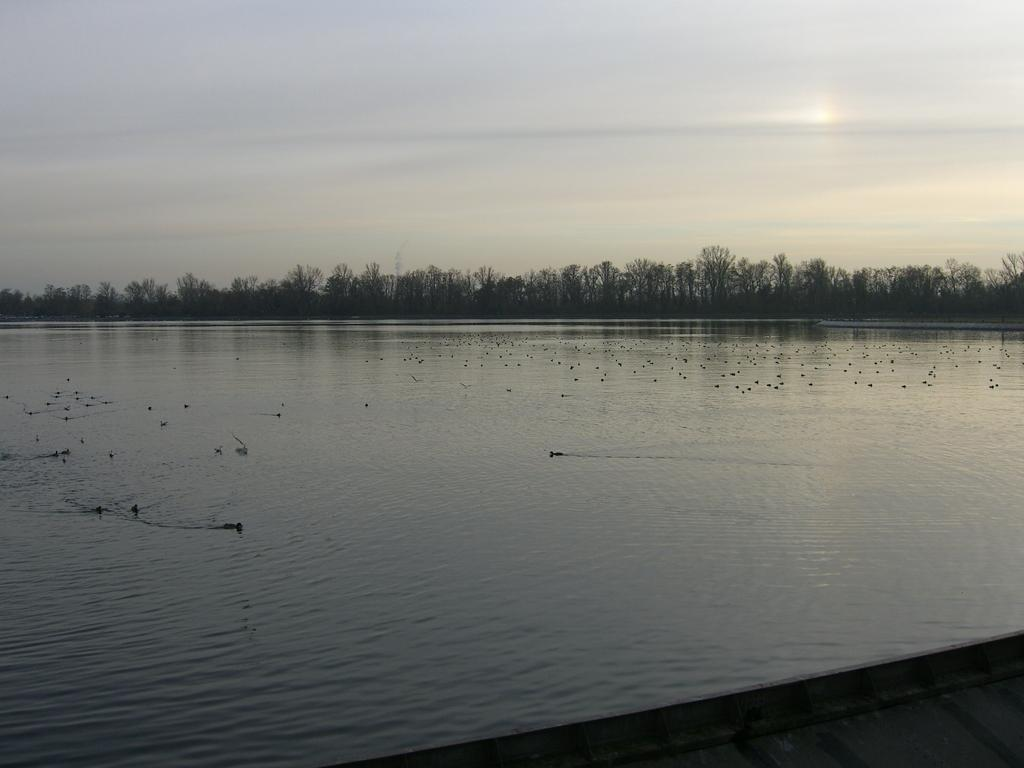What is the main feature of the image? There is a river in the picture. What are the birds doing in the image? The birds are swimming in the water. What can be seen in the background of the image? There are trees in the backdrop of the image. How would you describe the weather in the image? The sky is clear in the image, suggesting good weather. What type of holiday is being celebrated in the image? There is no indication of a holiday being celebrated in the image; it features a river, birds, trees, and a clear sky. What animal is shown walking along the riverbank in the image? There is no animal walking along the riverbank in the image; it only shows birds swimming in the water. 